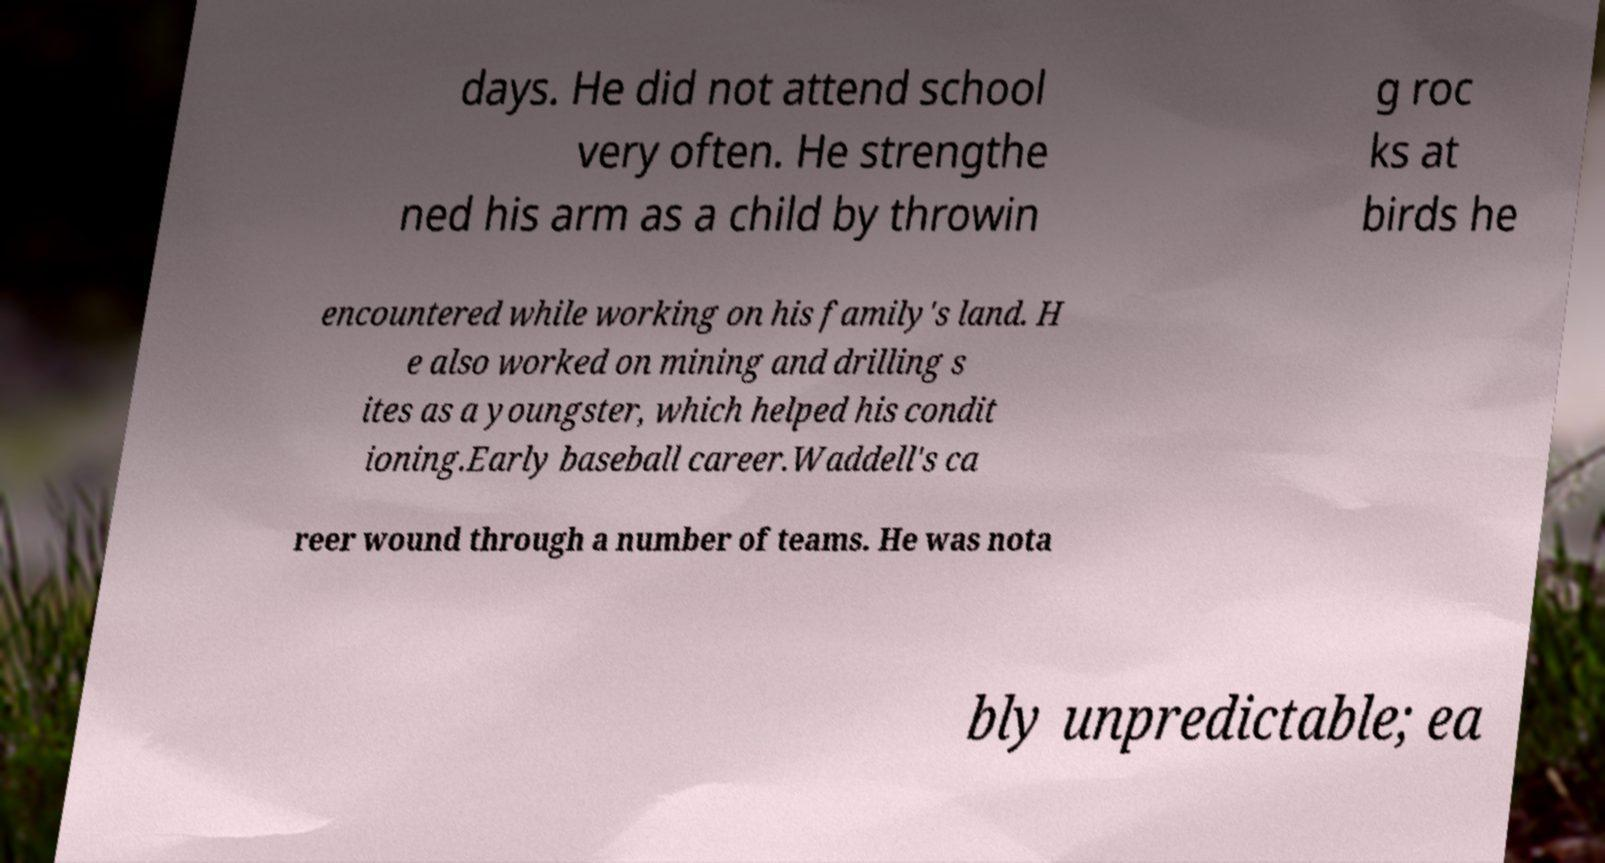Please read and relay the text visible in this image. What does it say? days. He did not attend school very often. He strengthe ned his arm as a child by throwin g roc ks at birds he encountered while working on his family's land. H e also worked on mining and drilling s ites as a youngster, which helped his condit ioning.Early baseball career.Waddell's ca reer wound through a number of teams. He was nota bly unpredictable; ea 